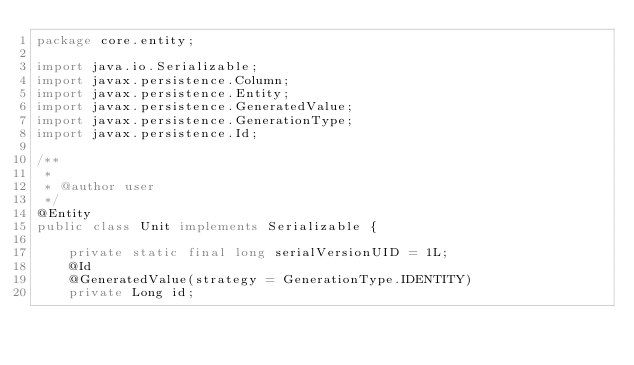Convert code to text. <code><loc_0><loc_0><loc_500><loc_500><_Java_>package core.entity;

import java.io.Serializable;
import javax.persistence.Column;
import javax.persistence.Entity;
import javax.persistence.GeneratedValue;
import javax.persistence.GenerationType;
import javax.persistence.Id;

/**
 *
 * @author user
 */
@Entity
public class Unit implements Serializable {

    private static final long serialVersionUID = 1L;
    @Id
    @GeneratedValue(strategy = GenerationType.IDENTITY)
    private Long id;</code> 